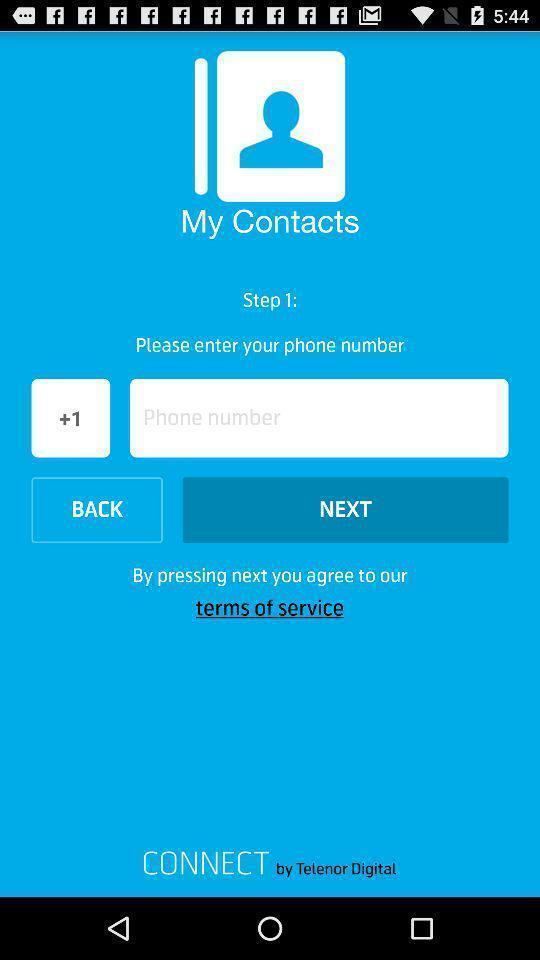Describe the content in this image. Registration page for a contact app. 